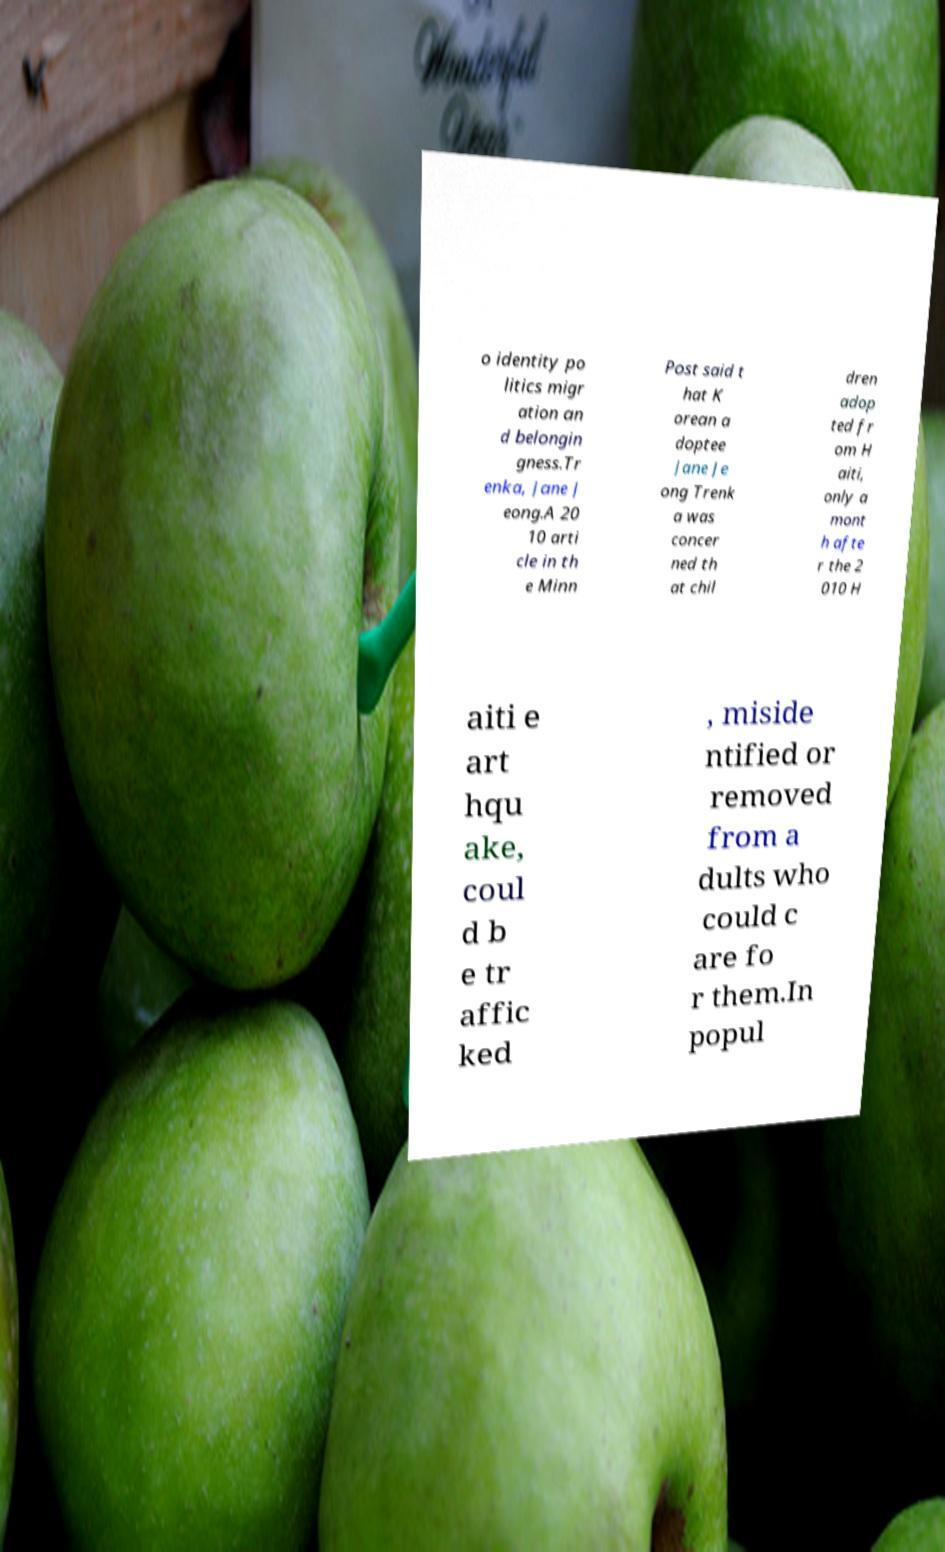Can you accurately transcribe the text from the provided image for me? o identity po litics migr ation an d belongin gness.Tr enka, Jane J eong.A 20 10 arti cle in th e Minn Post said t hat K orean a doptee Jane Je ong Trenk a was concer ned th at chil dren adop ted fr om H aiti, only a mont h afte r the 2 010 H aiti e art hqu ake, coul d b e tr affic ked , miside ntified or removed from a dults who could c are fo r them.In popul 